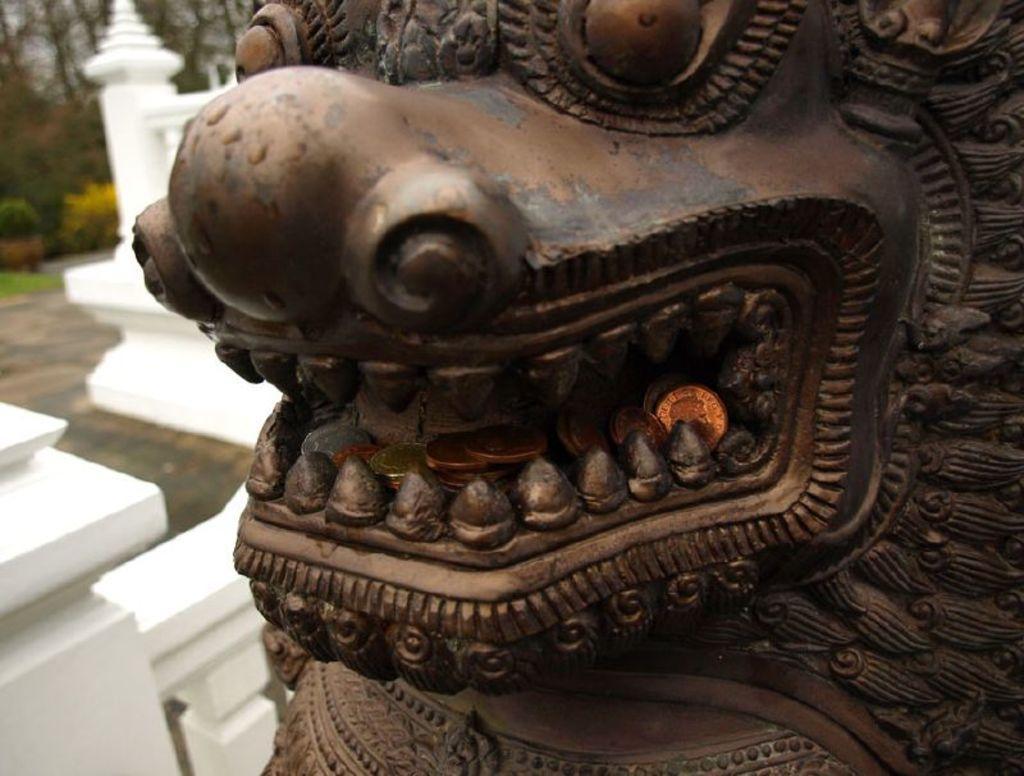Can you describe this image briefly? In this image I can see a brown colour thing and over here I can see number of coins. In the background I can see few white colour things, trees and I can see this image is little bit blurry from background. 